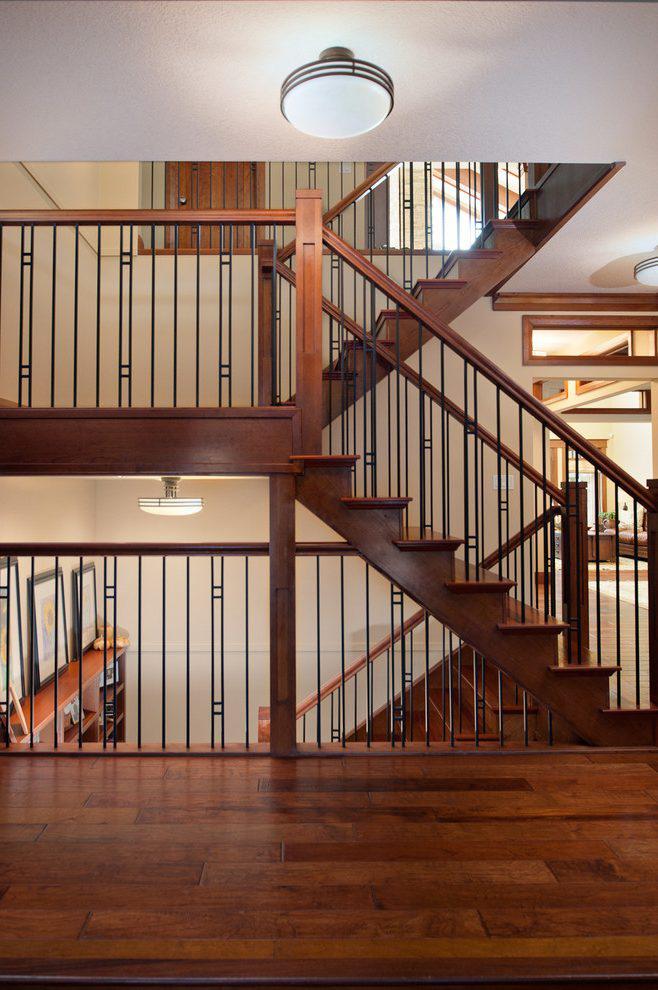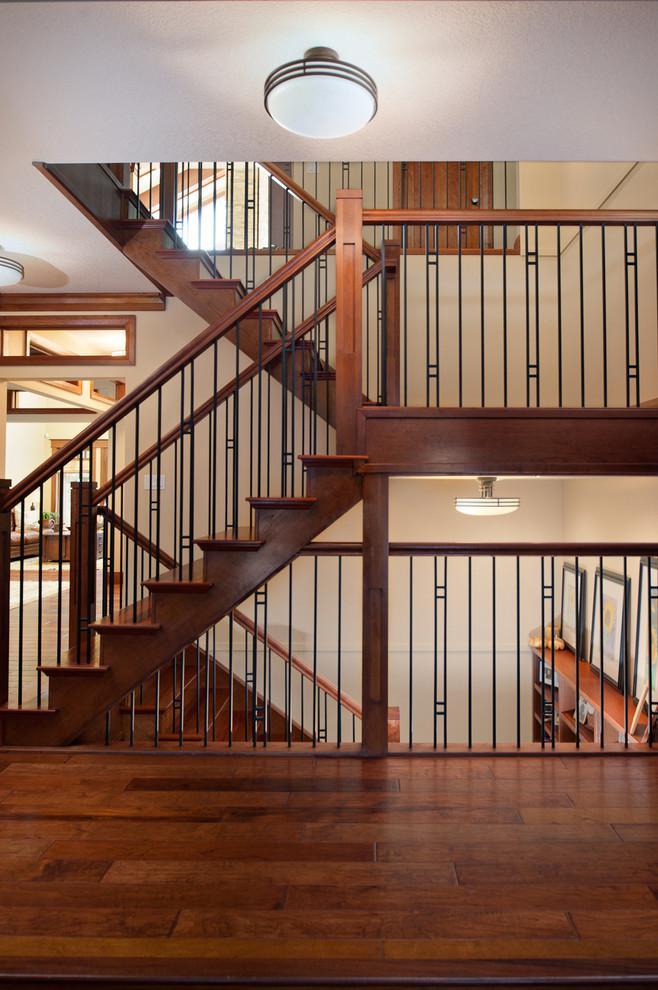The first image is the image on the left, the second image is the image on the right. For the images shown, is this caption "There is one set of stairs that has no risers." true? Answer yes or no. No. 